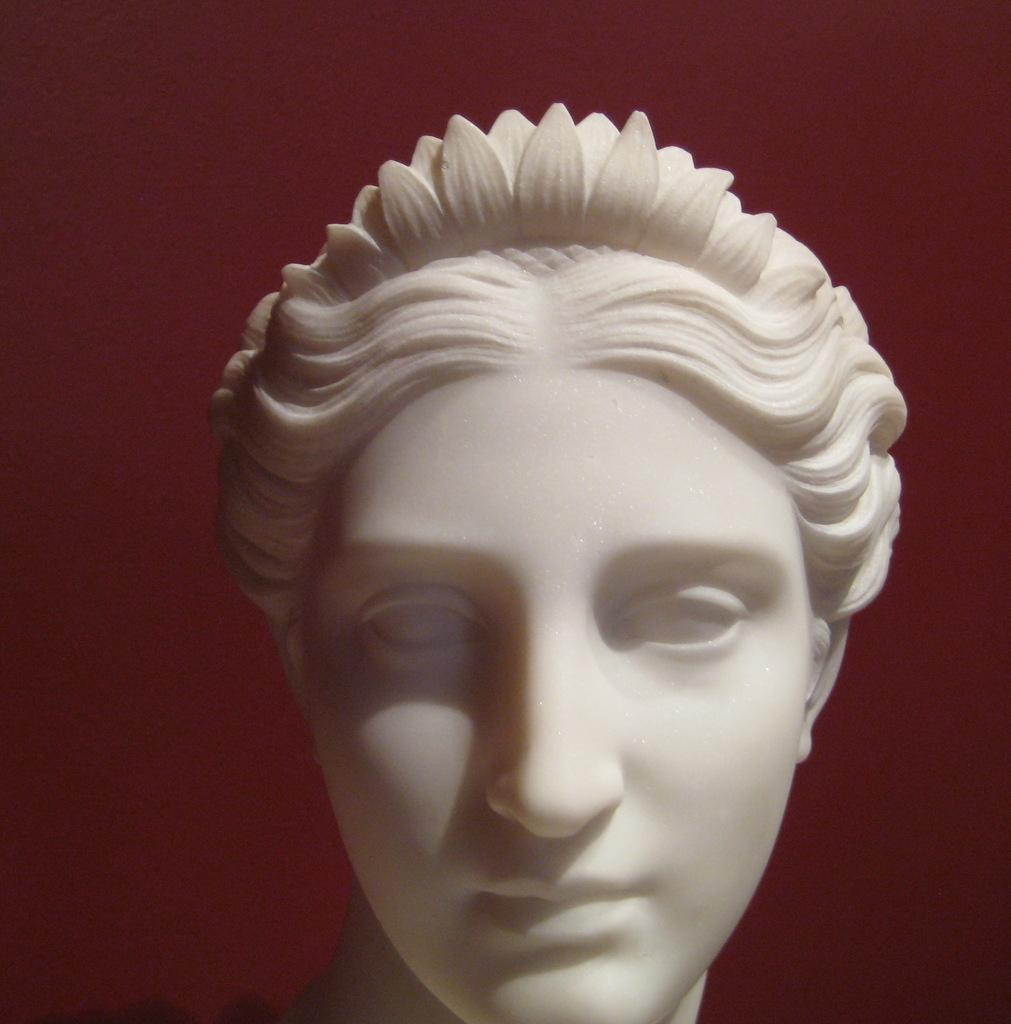What is the main subject of the image? There is a statue in the image. What can be observed about the background of the image? The background of the image is dark. What type of canvas is being used for the painting in the image? There is no painting or canvas present in the image; it features a statue. What attraction is being advertised in the image? There is no attraction being advertised in the image; it only shows a statue. 